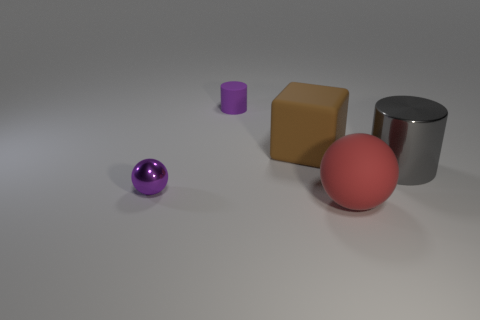Add 5 big green matte spheres. How many objects exist? 10 Subtract all cylinders. How many objects are left? 3 Add 2 tiny objects. How many tiny objects exist? 4 Subtract 0 brown cylinders. How many objects are left? 5 Subtract all red matte things. Subtract all metallic things. How many objects are left? 2 Add 2 red balls. How many red balls are left? 3 